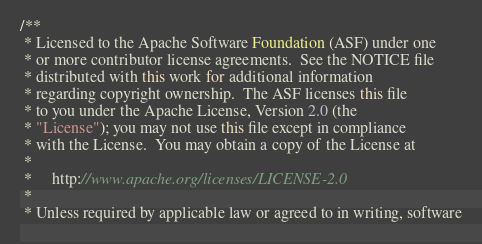Convert code to text. <code><loc_0><loc_0><loc_500><loc_500><_Java_>/**
 * Licensed to the Apache Software Foundation (ASF) under one
 * or more contributor license agreements.  See the NOTICE file
 * distributed with this work for additional information
 * regarding copyright ownership.  The ASF licenses this file
 * to you under the Apache License, Version 2.0 (the
 * "License"); you may not use this file except in compliance
 * with the License.  You may obtain a copy of the License at
 *
 *     http://www.apache.org/licenses/LICENSE-2.0
 *
 * Unless required by applicable law or agreed to in writing, software</code> 